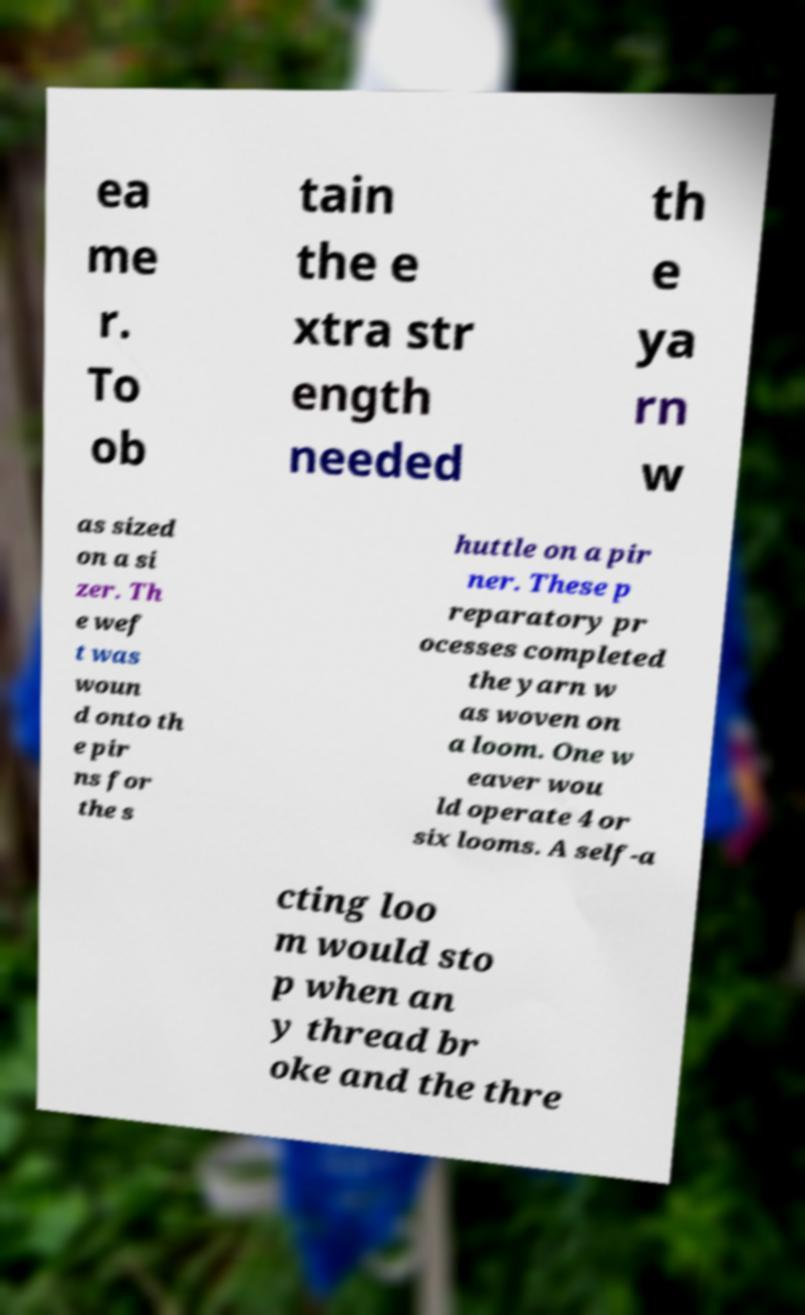Can you accurately transcribe the text from the provided image for me? ea me r. To ob tain the e xtra str ength needed th e ya rn w as sized on a si zer. Th e wef t was woun d onto th e pir ns for the s huttle on a pir ner. These p reparatory pr ocesses completed the yarn w as woven on a loom. One w eaver wou ld operate 4 or six looms. A self-a cting loo m would sto p when an y thread br oke and the thre 